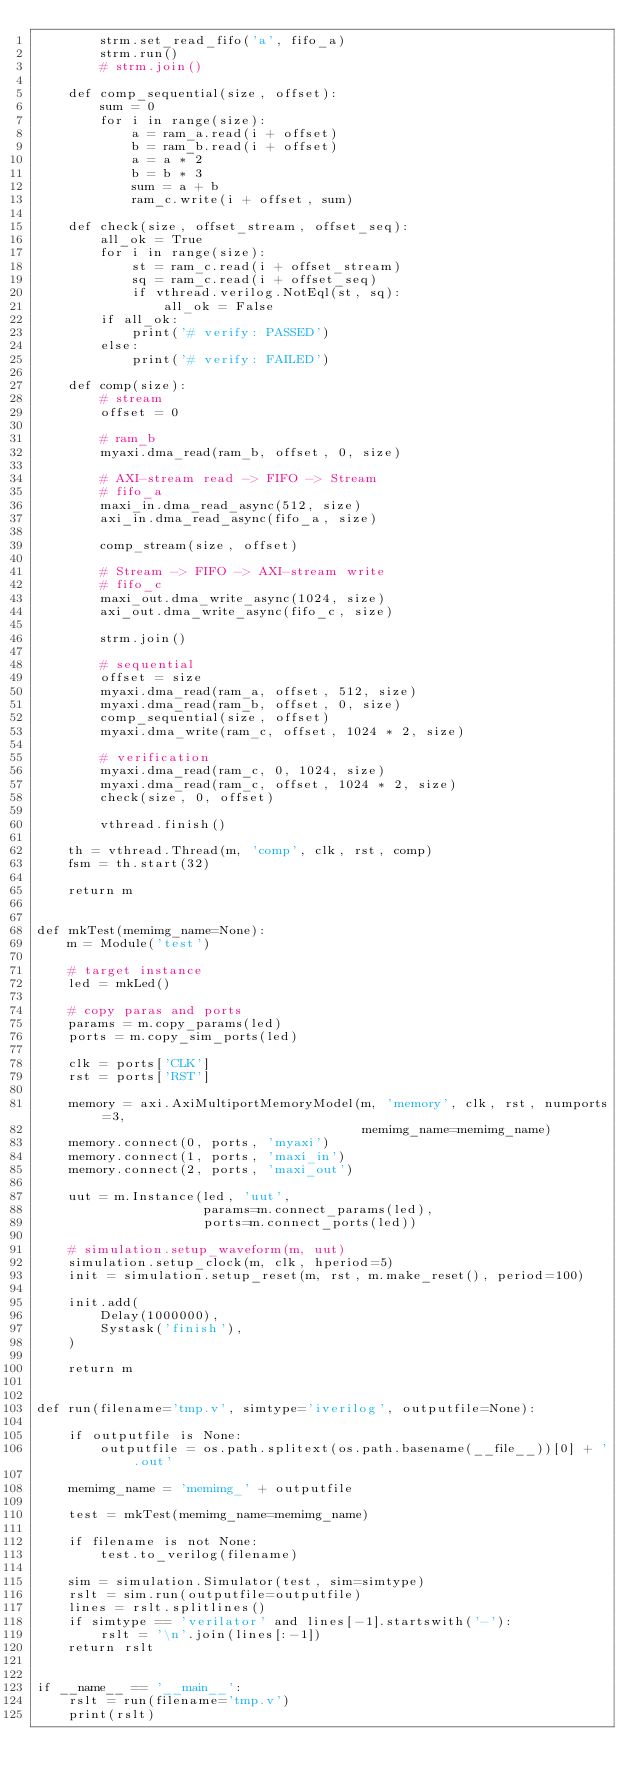<code> <loc_0><loc_0><loc_500><loc_500><_Python_>        strm.set_read_fifo('a', fifo_a)
        strm.run()
        # strm.join()

    def comp_sequential(size, offset):
        sum = 0
        for i in range(size):
            a = ram_a.read(i + offset)
            b = ram_b.read(i + offset)
            a = a * 2
            b = b * 3
            sum = a + b
            ram_c.write(i + offset, sum)

    def check(size, offset_stream, offset_seq):
        all_ok = True
        for i in range(size):
            st = ram_c.read(i + offset_stream)
            sq = ram_c.read(i + offset_seq)
            if vthread.verilog.NotEql(st, sq):
                all_ok = False
        if all_ok:
            print('# verify: PASSED')
        else:
            print('# verify: FAILED')

    def comp(size):
        # stream
        offset = 0

        # ram_b
        myaxi.dma_read(ram_b, offset, 0, size)

        # AXI-stream read -> FIFO -> Stream
        # fifo_a
        maxi_in.dma_read_async(512, size)
        axi_in.dma_read_async(fifo_a, size)

        comp_stream(size, offset)

        # Stream -> FIFO -> AXI-stream write
        # fifo_c
        maxi_out.dma_write_async(1024, size)
        axi_out.dma_write_async(fifo_c, size)

        strm.join()

        # sequential
        offset = size
        myaxi.dma_read(ram_a, offset, 512, size)
        myaxi.dma_read(ram_b, offset, 0, size)
        comp_sequential(size, offset)
        myaxi.dma_write(ram_c, offset, 1024 * 2, size)

        # verification
        myaxi.dma_read(ram_c, 0, 1024, size)
        myaxi.dma_read(ram_c, offset, 1024 * 2, size)
        check(size, 0, offset)

        vthread.finish()

    th = vthread.Thread(m, 'comp', clk, rst, comp)
    fsm = th.start(32)

    return m


def mkTest(memimg_name=None):
    m = Module('test')

    # target instance
    led = mkLed()

    # copy paras and ports
    params = m.copy_params(led)
    ports = m.copy_sim_ports(led)

    clk = ports['CLK']
    rst = ports['RST']

    memory = axi.AxiMultiportMemoryModel(m, 'memory', clk, rst, numports=3,
                                         memimg_name=memimg_name)
    memory.connect(0, ports, 'myaxi')
    memory.connect(1, ports, 'maxi_in')
    memory.connect(2, ports, 'maxi_out')

    uut = m.Instance(led, 'uut',
                     params=m.connect_params(led),
                     ports=m.connect_ports(led))

    # simulation.setup_waveform(m, uut)
    simulation.setup_clock(m, clk, hperiod=5)
    init = simulation.setup_reset(m, rst, m.make_reset(), period=100)

    init.add(
        Delay(1000000),
        Systask('finish'),
    )

    return m


def run(filename='tmp.v', simtype='iverilog', outputfile=None):

    if outputfile is None:
        outputfile = os.path.splitext(os.path.basename(__file__))[0] + '.out'

    memimg_name = 'memimg_' + outputfile

    test = mkTest(memimg_name=memimg_name)

    if filename is not None:
        test.to_verilog(filename)

    sim = simulation.Simulator(test, sim=simtype)
    rslt = sim.run(outputfile=outputfile)
    lines = rslt.splitlines()
    if simtype == 'verilator' and lines[-1].startswith('-'):
        rslt = '\n'.join(lines[:-1])
    return rslt


if __name__ == '__main__':
    rslt = run(filename='tmp.v')
    print(rslt)
</code> 